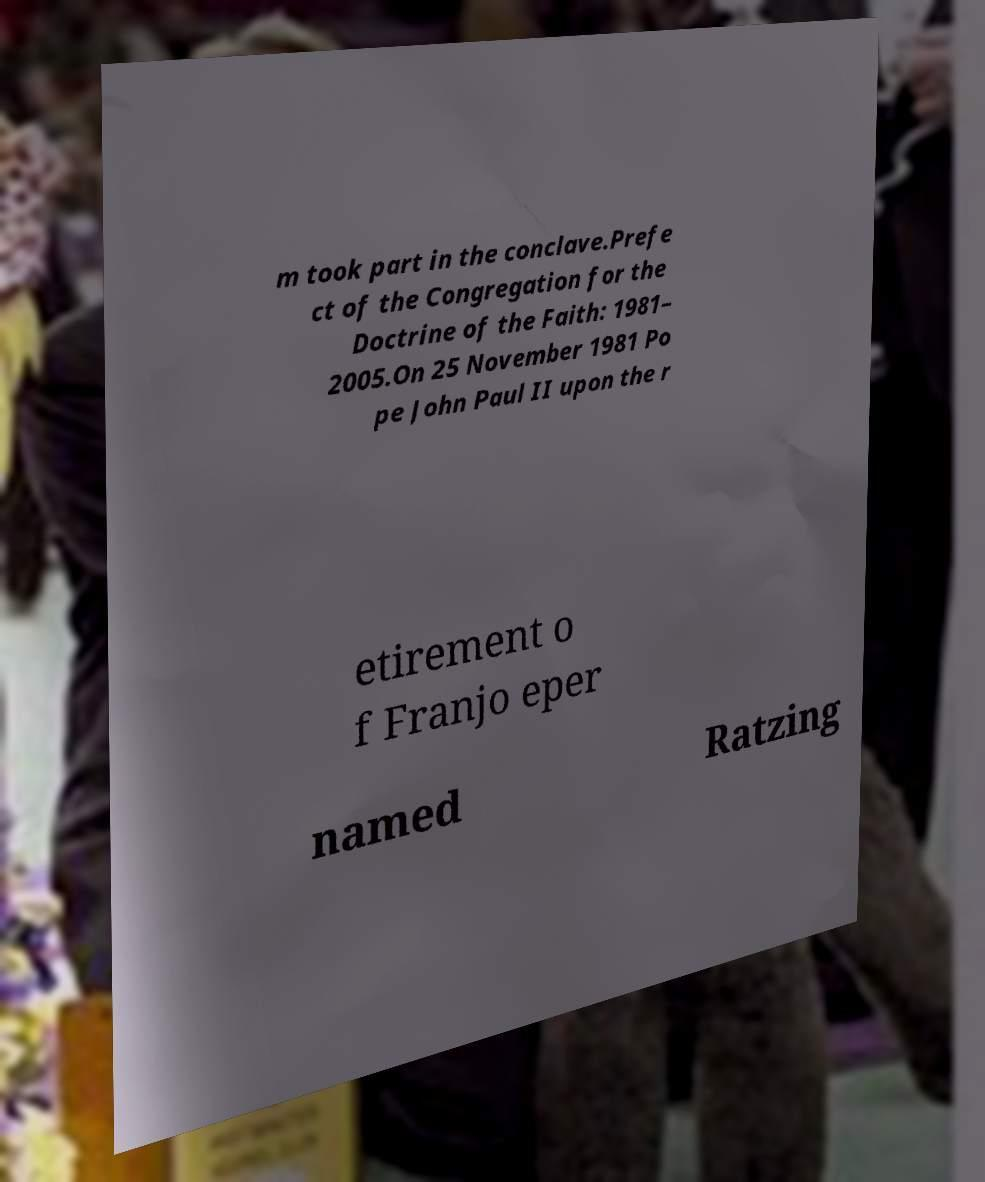Could you assist in decoding the text presented in this image and type it out clearly? m took part in the conclave.Prefe ct of the Congregation for the Doctrine of the Faith: 1981– 2005.On 25 November 1981 Po pe John Paul II upon the r etirement o f Franjo eper named Ratzing 